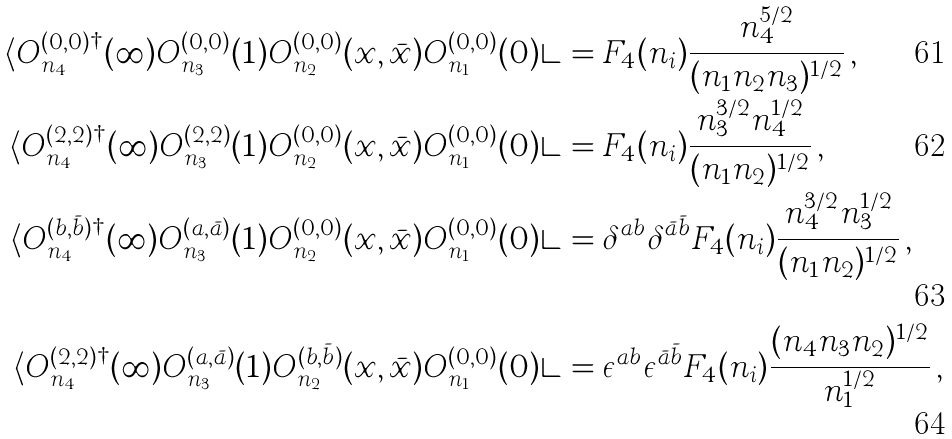<formula> <loc_0><loc_0><loc_500><loc_500>\langle O ^ { ( 0 , 0 ) \dagger } _ { n _ { 4 } } ( \infty ) O ^ { ( 0 , 0 ) } _ { n _ { 3 } } ( 1 ) O ^ { ( 0 , 0 ) } _ { n _ { 2 } } ( x , \bar { x } ) O ^ { ( 0 , 0 ) } _ { n _ { 1 } } ( 0 ) \rangle & = F _ { 4 } ( n _ { i } ) \frac { n _ { 4 } ^ { 5 / 2 } } { ( n _ { 1 } n _ { 2 } n _ { 3 } ) ^ { 1 / 2 } } \, , \\ \langle O ^ { ( 2 , 2 ) \dagger } _ { n _ { 4 } } ( \infty ) O ^ { ( 2 , 2 ) } _ { n _ { 3 } } ( 1 ) O ^ { ( 0 , 0 ) } _ { n _ { 2 } } ( x , \bar { x } ) O ^ { ( 0 , 0 ) } _ { n _ { 1 } } ( 0 ) \rangle & = F _ { 4 } ( n _ { i } ) \frac { n _ { 3 } ^ { 3 / 2 } n _ { 4 } ^ { 1 / 2 } } { ( n _ { 1 } n _ { 2 } ) ^ { 1 / 2 } } \, , \\ \langle O ^ { ( b , \bar { b } ) \dagger } _ { n _ { 4 } } ( \infty ) O ^ { ( a , \bar { a } ) } _ { n _ { 3 } } ( 1 ) O ^ { ( 0 , 0 ) } _ { n _ { 2 } } ( x , \bar { x } ) O ^ { ( 0 , 0 ) } _ { n _ { 1 } } ( 0 ) \rangle & = \delta ^ { a b } \delta ^ { \bar { a } \bar { b } } F _ { 4 } ( n _ { i } ) \frac { n _ { 4 } ^ { 3 / 2 } n _ { 3 } ^ { 1 / 2 } } { ( n _ { 1 } n _ { 2 } ) ^ { 1 / 2 } } \, , \\ \langle O ^ { ( 2 , 2 ) \dagger } _ { n _ { 4 } } ( \infty ) O ^ { ( a , \bar { a } ) } _ { n _ { 3 } } ( 1 ) O ^ { ( b , \bar { b } ) } _ { n _ { 2 } } ( x , \bar { x } ) O ^ { ( 0 , 0 ) } _ { n _ { 1 } } ( 0 ) \rangle & = \epsilon ^ { a b } \epsilon ^ { \bar { a } \bar { b } } F _ { 4 } ( n _ { i } ) \frac { ( n _ { 4 } n _ { 3 } n _ { 2 } ) ^ { 1 / 2 } } { n _ { 1 } ^ { 1 / 2 } } \, ,</formula> 